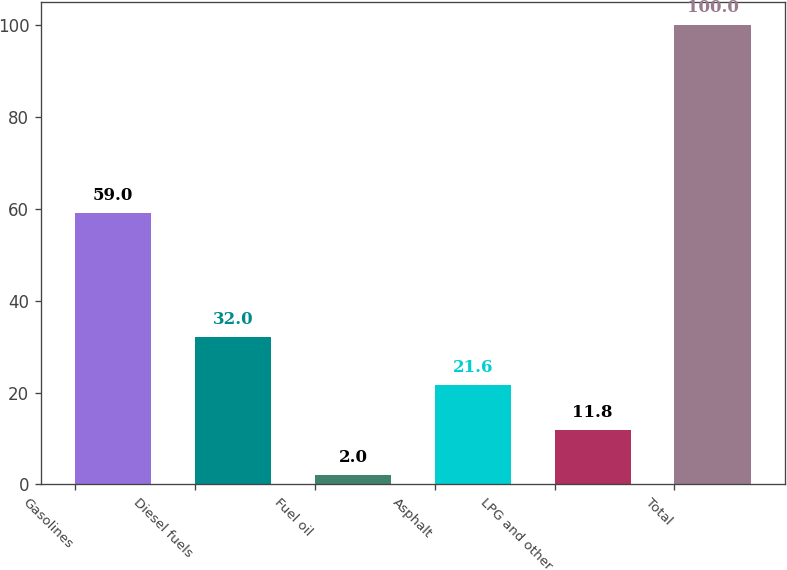Convert chart to OTSL. <chart><loc_0><loc_0><loc_500><loc_500><bar_chart><fcel>Gasolines<fcel>Diesel fuels<fcel>Fuel oil<fcel>Asphalt<fcel>LPG and other<fcel>Total<nl><fcel>59<fcel>32<fcel>2<fcel>21.6<fcel>11.8<fcel>100<nl></chart> 